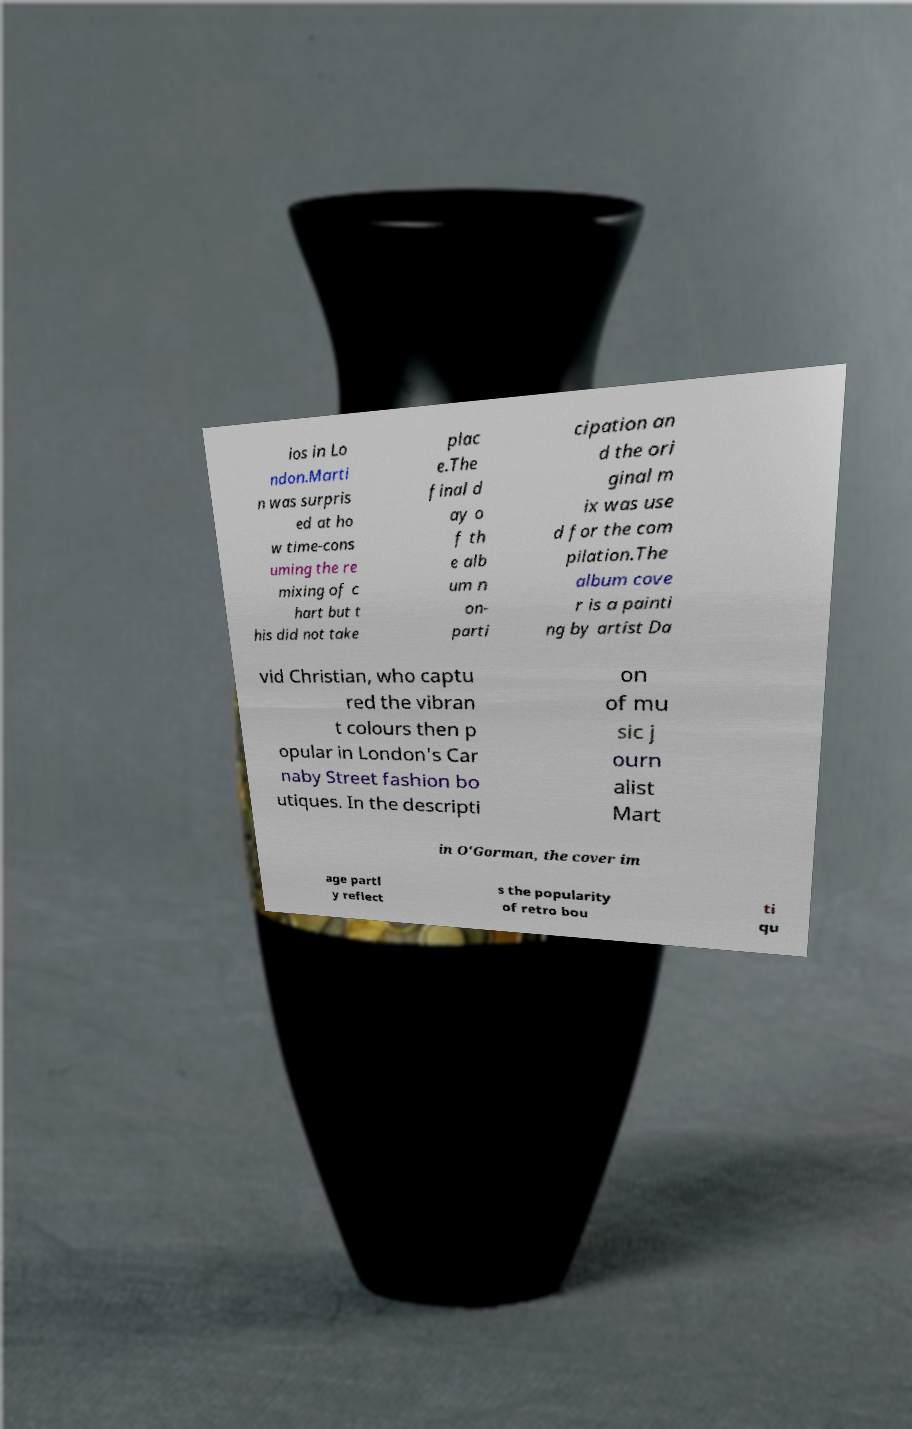What messages or text are displayed in this image? I need them in a readable, typed format. ios in Lo ndon.Marti n was surpris ed at ho w time-cons uming the re mixing of c hart but t his did not take plac e.The final d ay o f th e alb um n on- parti cipation an d the ori ginal m ix was use d for the com pilation.The album cove r is a painti ng by artist Da vid Christian, who captu red the vibran t colours then p opular in London's Car naby Street fashion bo utiques. In the descripti on of mu sic j ourn alist Mart in O'Gorman, the cover im age partl y reflect s the popularity of retro bou ti qu 